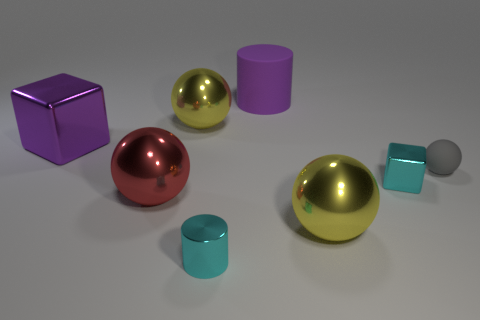Subtract all large red balls. How many balls are left? 3 Subtract all yellow cylinders. How many yellow balls are left? 2 Subtract all gray spheres. How many spheres are left? 3 Add 2 tiny green matte spheres. How many objects exist? 10 Subtract 1 balls. How many balls are left? 3 Subtract all red balls. Subtract all blue blocks. How many balls are left? 3 Add 5 large red objects. How many large red objects exist? 6 Subtract 1 purple cylinders. How many objects are left? 7 Subtract all blocks. How many objects are left? 6 Subtract all tiny purple things. Subtract all yellow metallic objects. How many objects are left? 6 